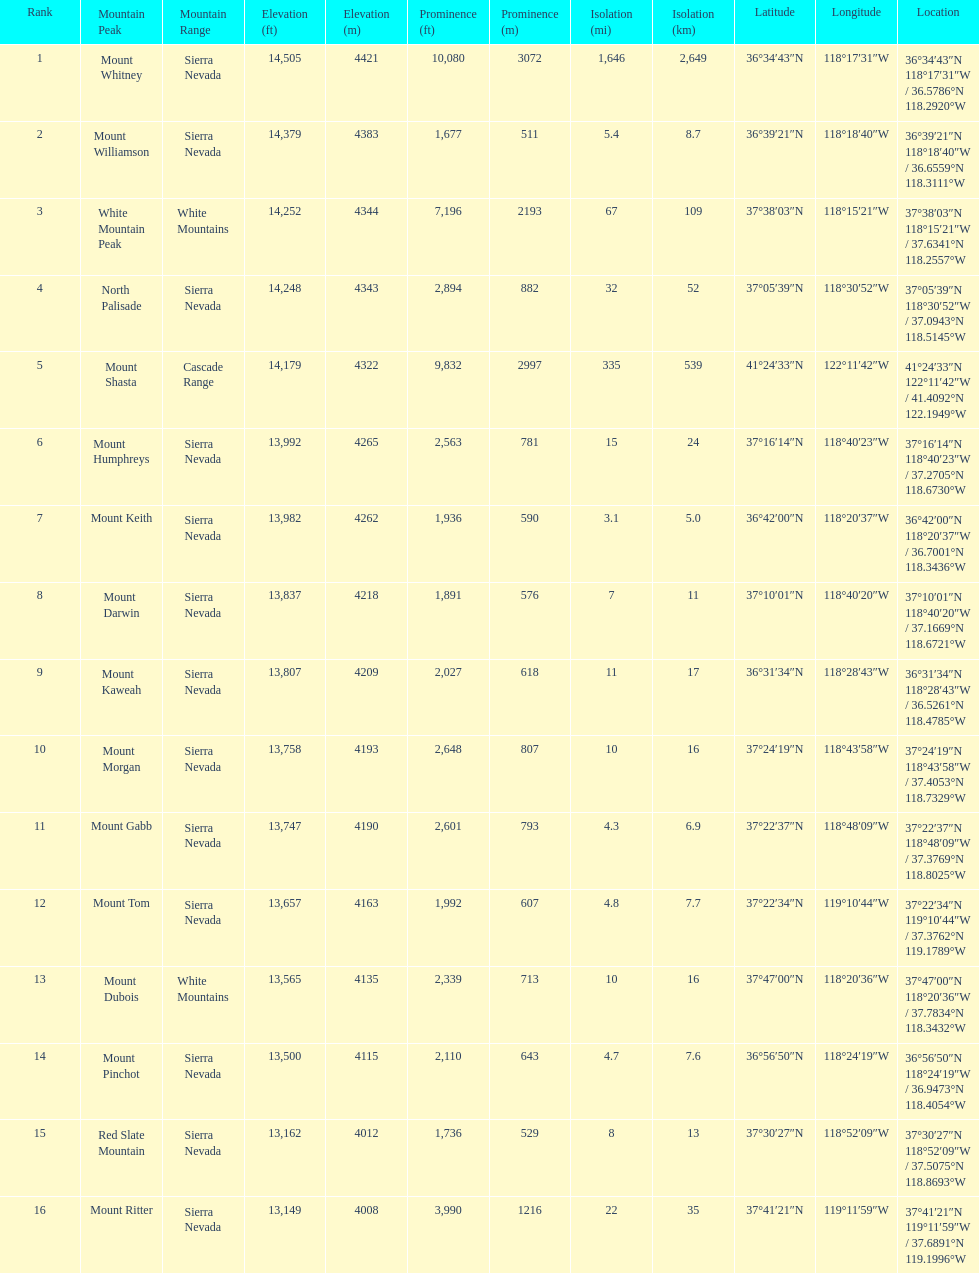What is the tallest peak in the sierra nevadas? Mount Whitney. 